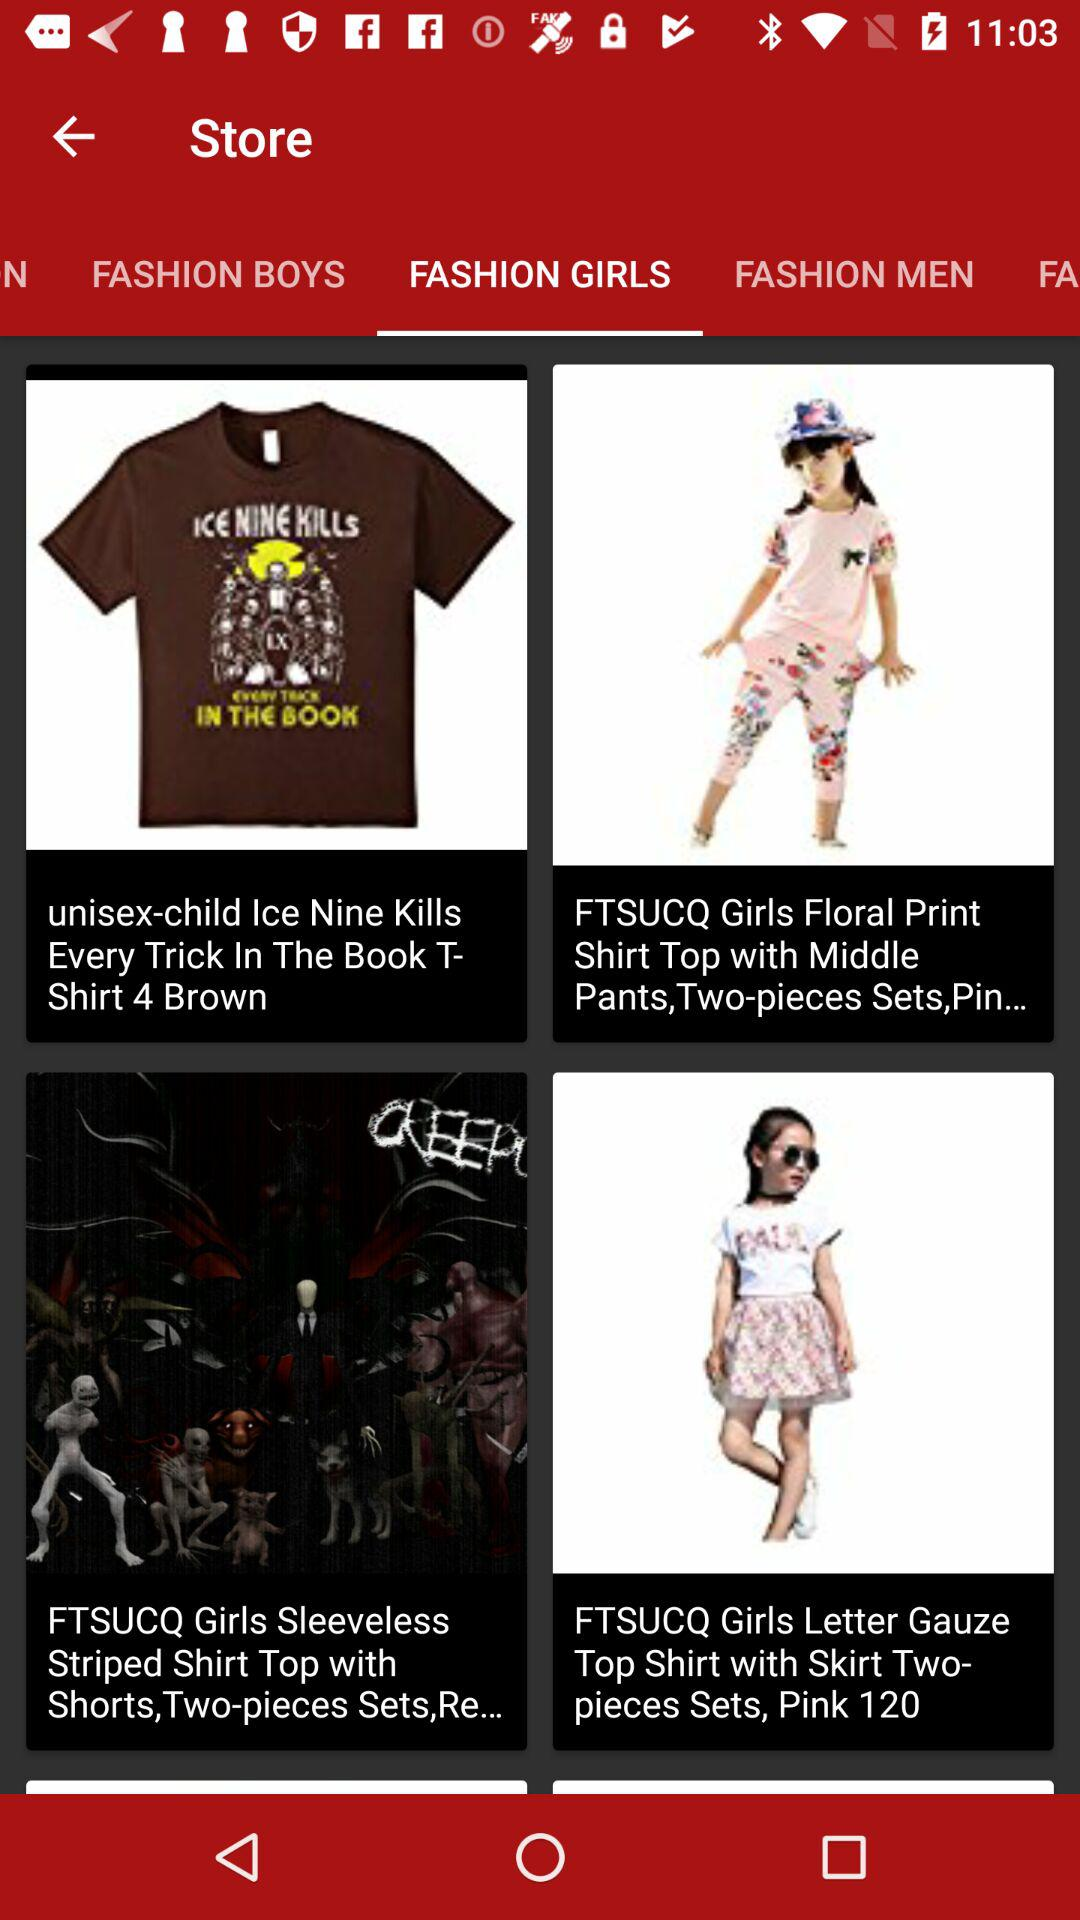What's the total number of pieces in a set of "FTSUCQ Girls Sleeveless Striped Shirt Top with Shorts"? There are two pieces in a set of "FTSUCQ Girls Sleeveless Striped Shirt Top with Shorts". 